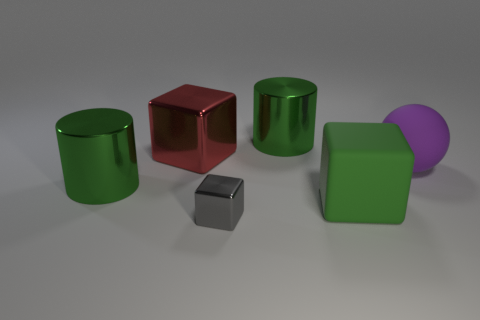Add 4 gray blocks. How many objects exist? 10 Subtract all spheres. How many objects are left? 5 Add 4 large rubber cubes. How many large rubber cubes exist? 5 Subtract 0 brown cylinders. How many objects are left? 6 Subtract all brown rubber objects. Subtract all big cylinders. How many objects are left? 4 Add 6 purple spheres. How many purple spheres are left? 7 